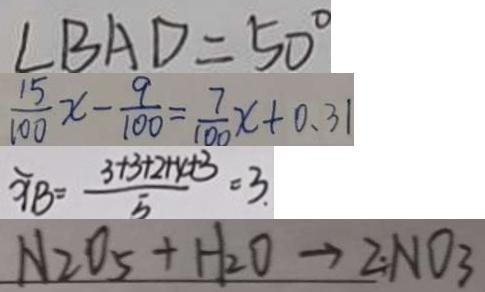<formula> <loc_0><loc_0><loc_500><loc_500>\angle B A D = 5 0 ^ { \circ } 
 \frac { 1 5 } { 1 0 0 } x - \frac { 9 } { 1 0 0 } = \frac { 7 } { 1 0 0 } x + 0 . 3 1 
 \widehat { X B } = \frac { 3 + 3 + 2 + 4 + 3 } { 5 } = 3 
 N _ { 2 } O _ { 5 } + H _ { 2 } O \rightarrow 2 N O _ { 3 }</formula> 